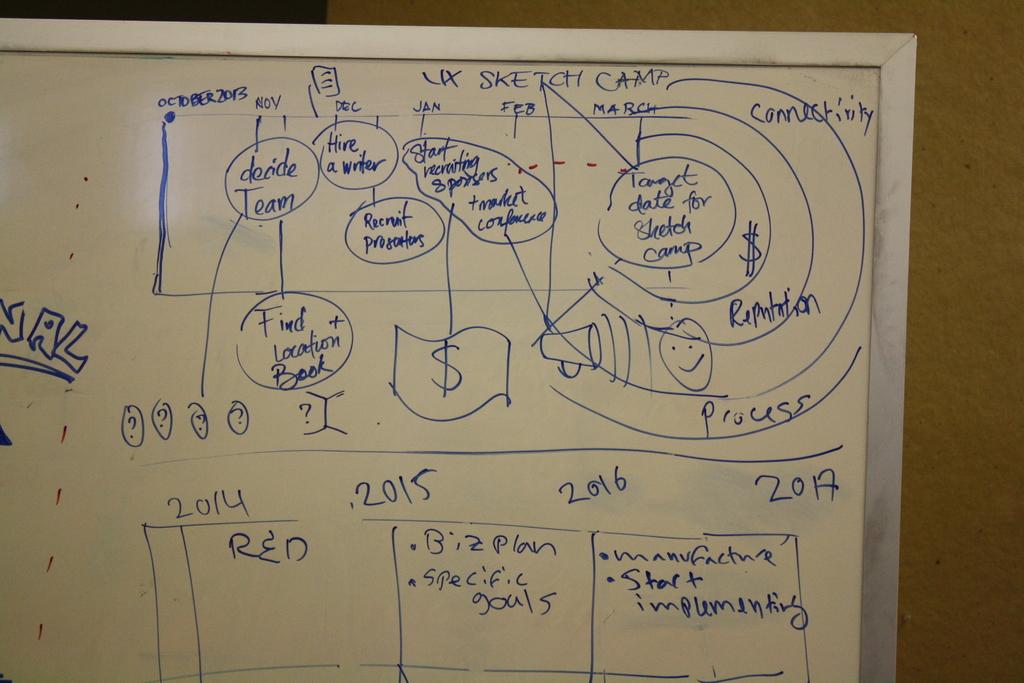What color was in 2014?
Your answer should be compact. Red. Whats the last year written on the board?
Make the answer very short. 2017. 